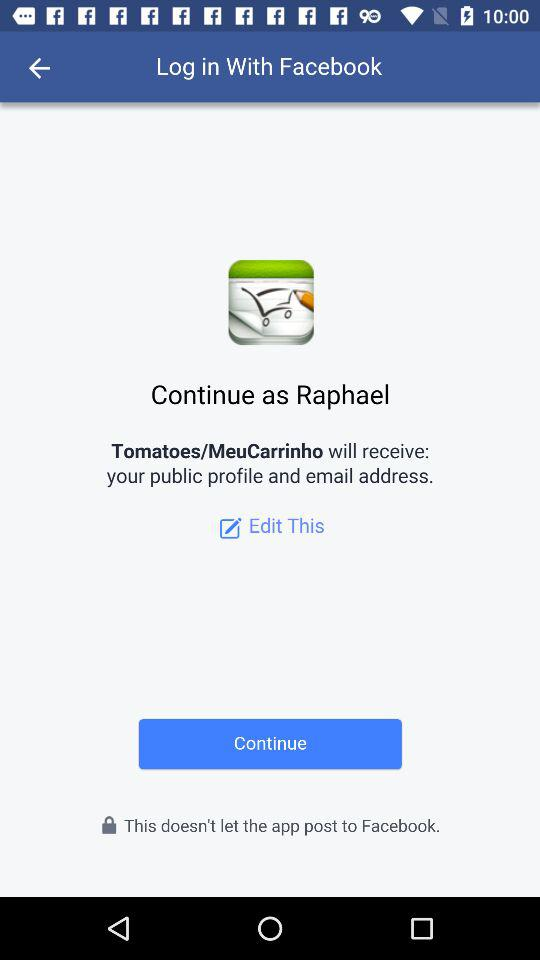What application will receive my public profile and email address? The application is "Tomatoes/MenuCarrinho". 